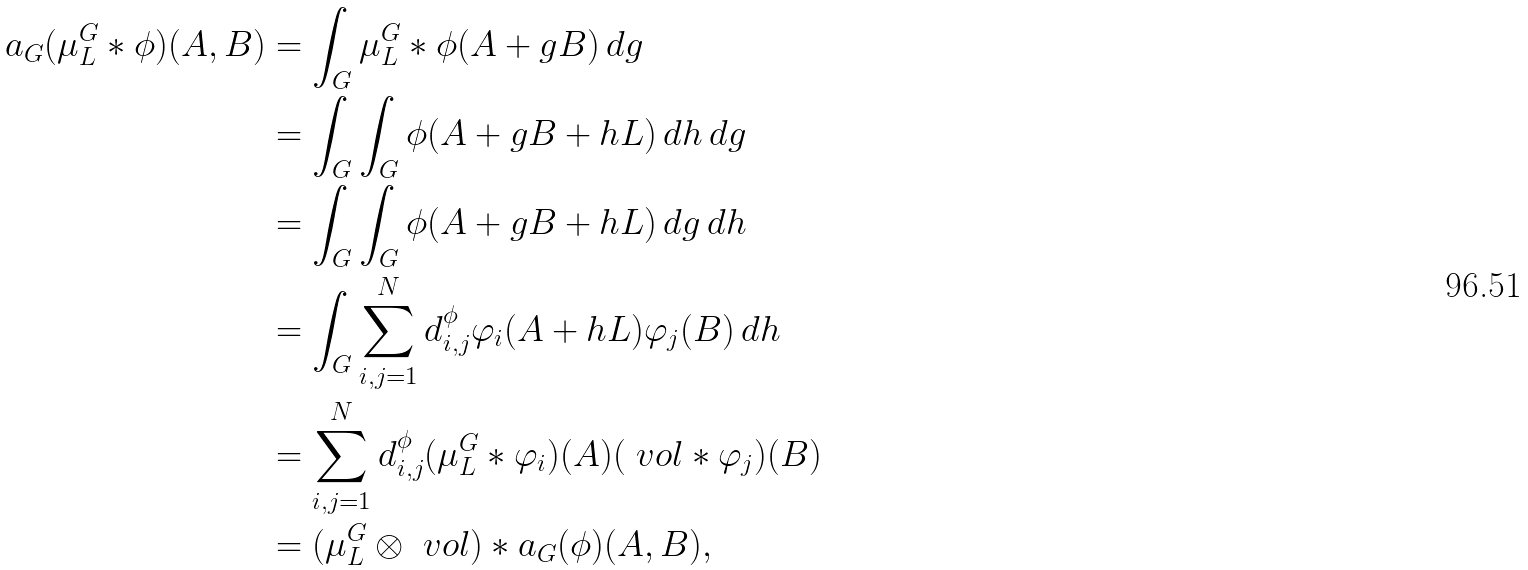<formula> <loc_0><loc_0><loc_500><loc_500>a _ { G } ( \mu _ { L } ^ { G } * \phi ) ( A , B ) & = \int _ { G } \mu _ { L } ^ { G } * \phi ( A + g B ) \, d g \\ & = \int _ { G } \int _ { G } \phi ( A + g B + h L ) \, d h \, d g \\ & = \int _ { G } \int _ { G } \phi ( A + g B + h L ) \, d g \, d h \\ & = \int _ { G } \sum _ { i , j = 1 } ^ { N } d _ { i , j } ^ { \phi } \varphi _ { i } ( A + h L ) \varphi _ { j } ( B ) \, d h \\ & = \sum _ { i , j = 1 } ^ { N } d _ { i , j } ^ { \phi } ( \mu _ { L } ^ { G } * \varphi _ { i } ) ( A ) ( \ v o l * \varphi _ { j } ) ( B ) \\ & = ( \mu _ { L } ^ { G } \otimes \ v o l ) * a _ { G } ( \phi ) ( A , B ) ,</formula> 